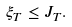Convert formula to latex. <formula><loc_0><loc_0><loc_500><loc_500>\xi _ { T } \leq J _ { T } .</formula> 